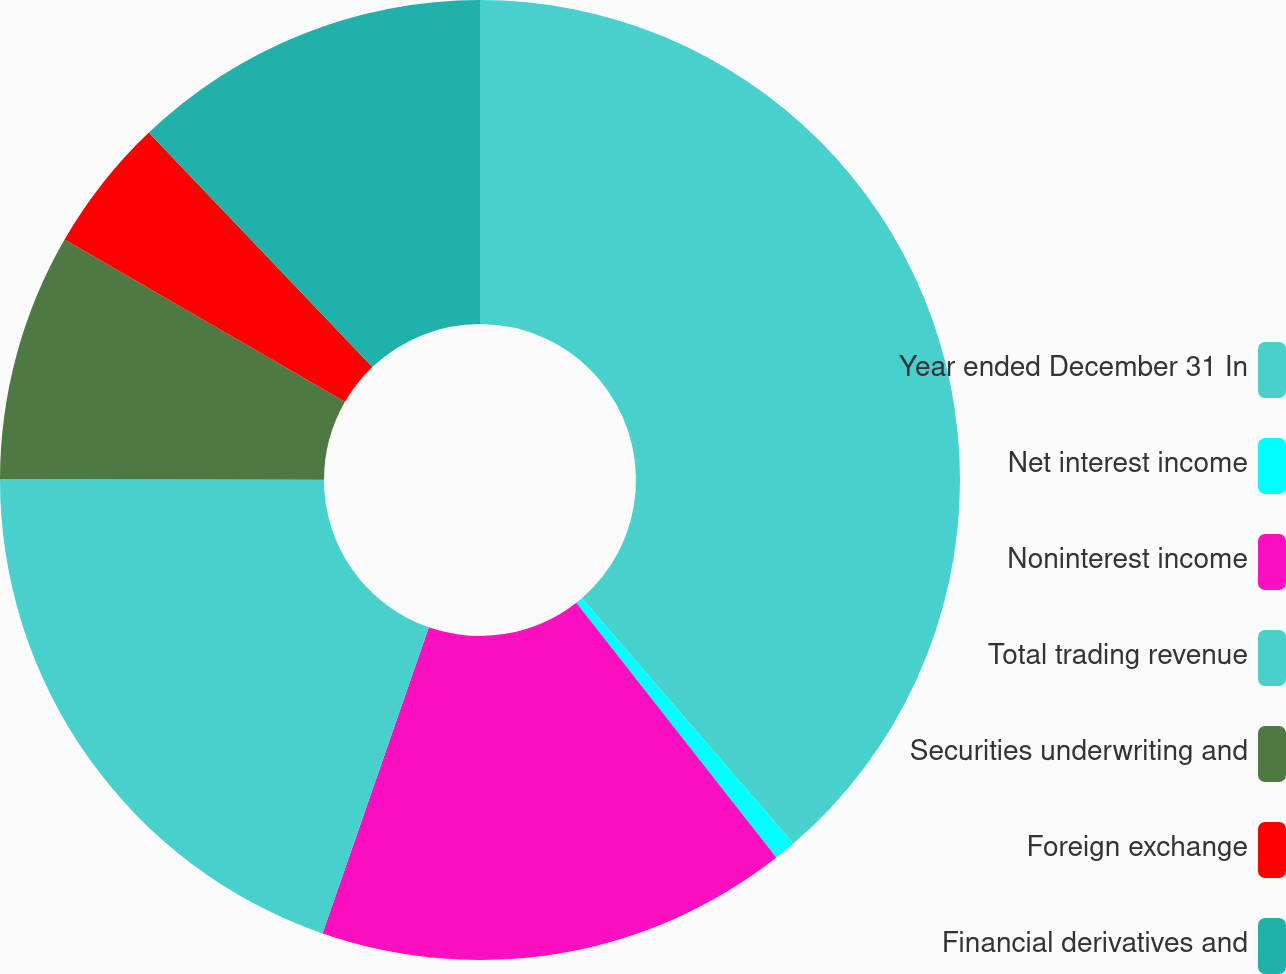Convert chart. <chart><loc_0><loc_0><loc_500><loc_500><pie_chart><fcel>Year ended December 31 In<fcel>Net interest income<fcel>Noninterest income<fcel>Total trading revenue<fcel>Securities underwriting and<fcel>Foreign exchange<fcel>Financial derivatives and<nl><fcel>38.68%<fcel>0.73%<fcel>15.91%<fcel>19.71%<fcel>8.32%<fcel>4.53%<fcel>12.12%<nl></chart> 